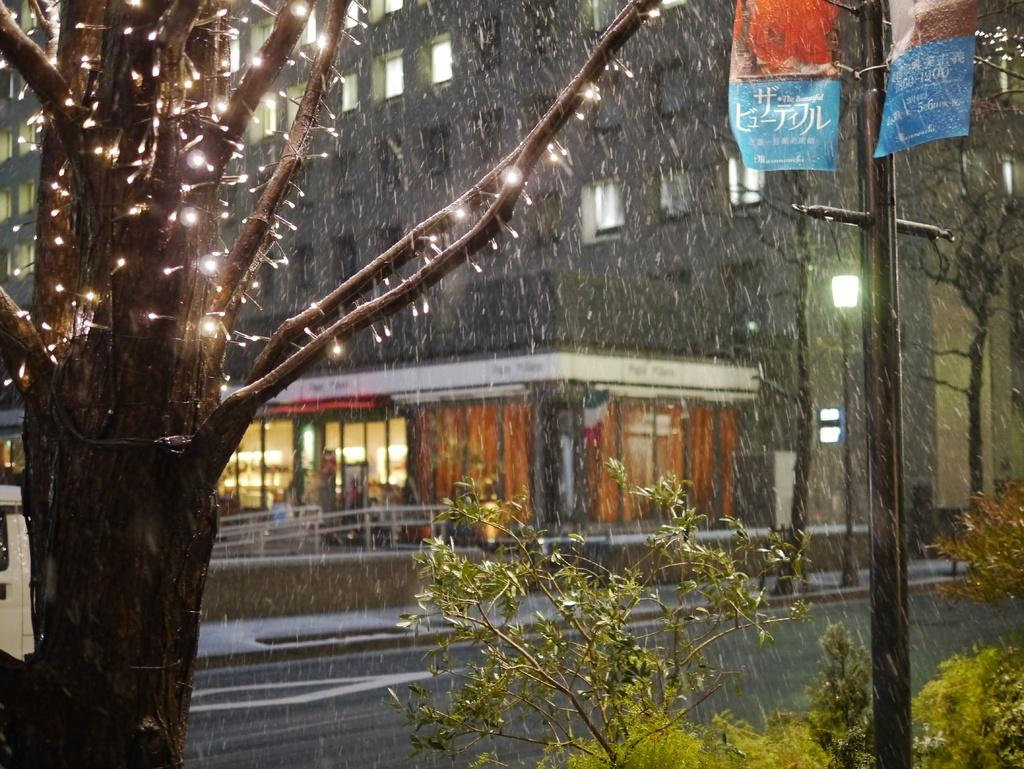What is illuminated on the tree in the image? There are lights on the tree. What other types of vegetation are near the tree? There are plants beside the tree. What is located near the tree? There is a pole near the tree. What can be seen in the foreground of the image? There is a road in front of the tree and pole. What structures are visible in the image? There are buildings visible in the image. What type of screw can be seen holding the meat on the scale in the image? There is no screw, meat, or scale present in the image. What type of scale is used to weigh the plants beside the tree? There is no scale present in the image, and the plants are not being weighed. 